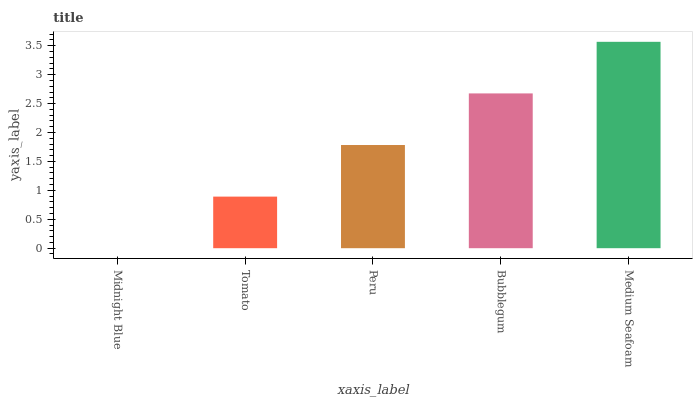Is Midnight Blue the minimum?
Answer yes or no. Yes. Is Medium Seafoam the maximum?
Answer yes or no. Yes. Is Tomato the minimum?
Answer yes or no. No. Is Tomato the maximum?
Answer yes or no. No. Is Tomato greater than Midnight Blue?
Answer yes or no. Yes. Is Midnight Blue less than Tomato?
Answer yes or no. Yes. Is Midnight Blue greater than Tomato?
Answer yes or no. No. Is Tomato less than Midnight Blue?
Answer yes or no. No. Is Peru the high median?
Answer yes or no. Yes. Is Peru the low median?
Answer yes or no. Yes. Is Bubblegum the high median?
Answer yes or no. No. Is Bubblegum the low median?
Answer yes or no. No. 